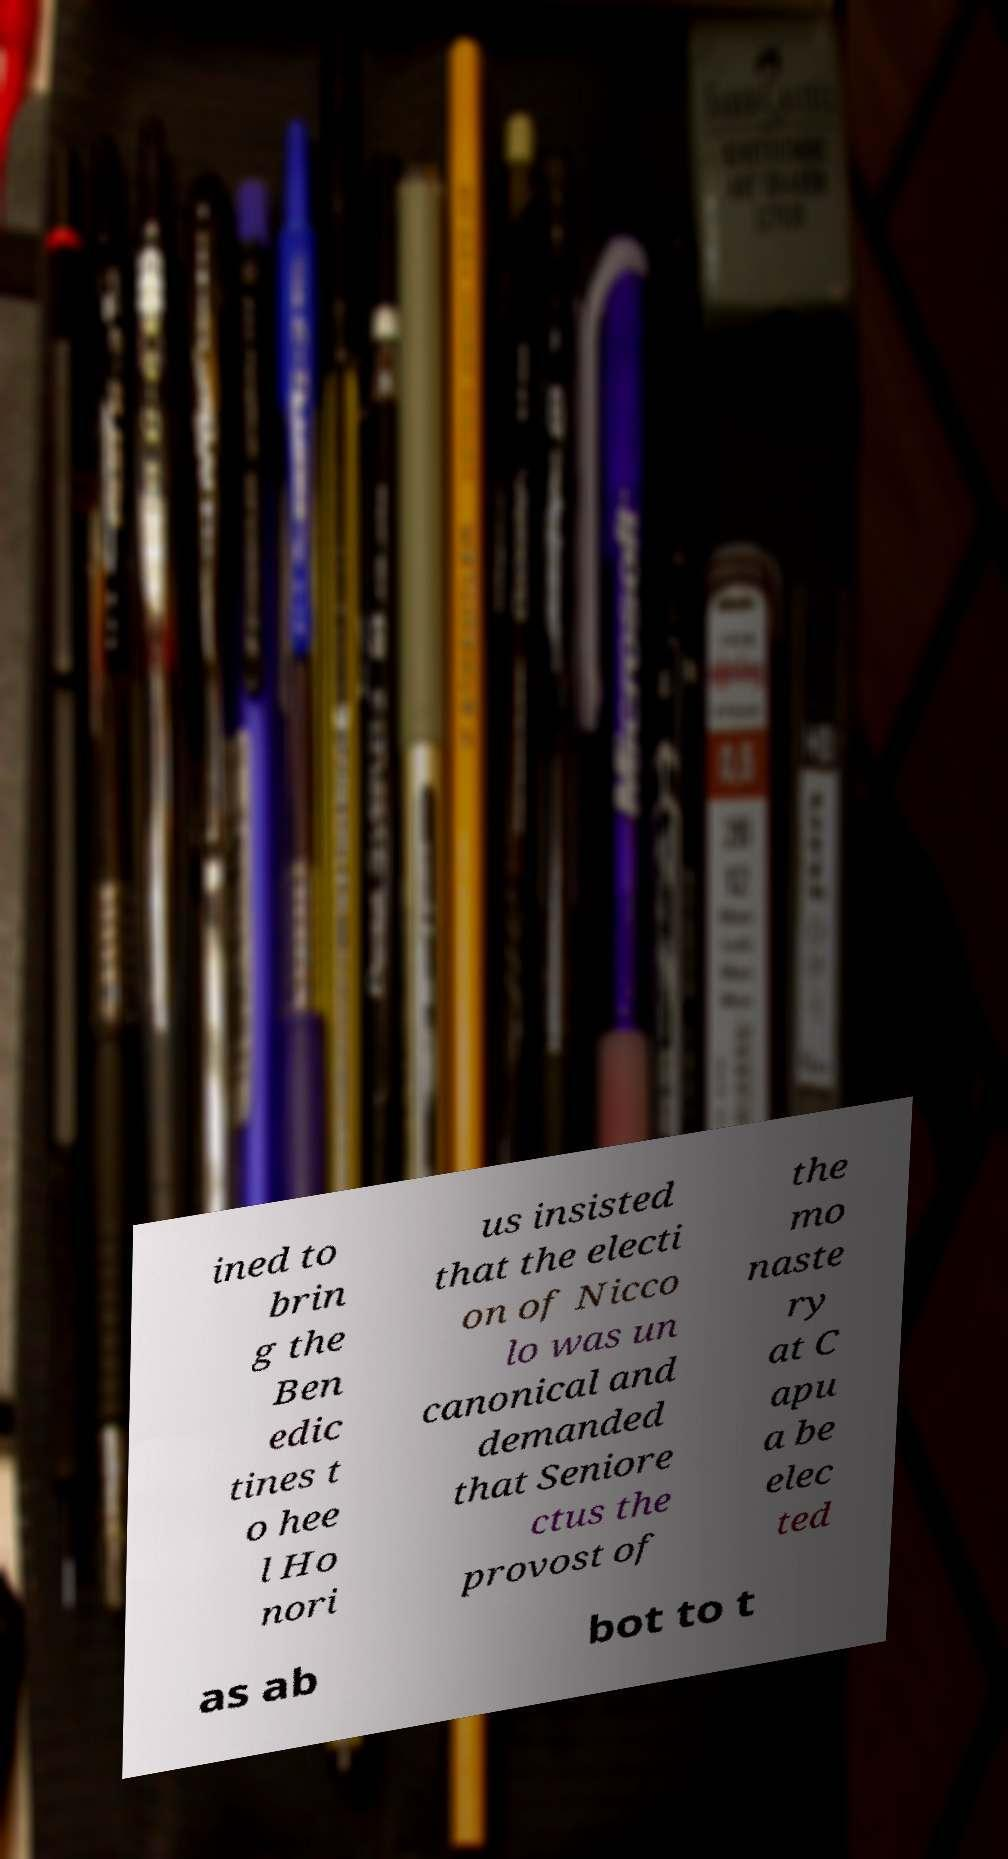Please read and relay the text visible in this image. What does it say? ined to brin g the Ben edic tines t o hee l Ho nori us insisted that the electi on of Nicco lo was un canonical and demanded that Seniore ctus the provost of the mo naste ry at C apu a be elec ted as ab bot to t 